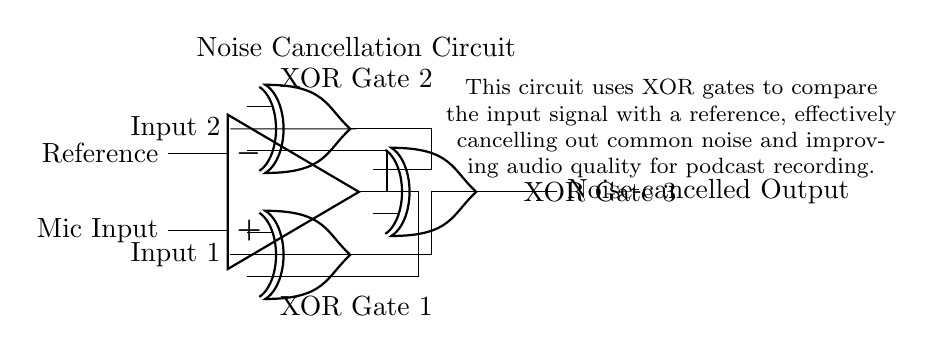What is the type of the main logic gates used in this circuit? The main logic gates used in this circuit are XOR gates, indicated by the symbols labeled in the diagram.
Answer: XOR gates How many XOR gates are present in the circuit? There are three XOR gates shown in the circuit, as seen from the labels beside the symbols.
Answer: Three What is the purpose of the operational amplifier in this circuit? The operational amplifier serves to amplify the microphone input signal, which is then fed into the XOR gates for noise cancellation.
Answer: Amplification What is the output of the circuit labeled as? The output of the circuit is labeled as "Noise-cancelled Output," indicating that the function of the circuit is to reduce unwanted noise.
Answer: Noise-cancelled Output How do the XOR gates contribute to noise cancellation? The XOR gates compare the input signal to a reference signal and effectively cancel out common noises by outputting only the differences.
Answer: By comparing signals Which signals are being input to the first XOR gate? The first XOR gate receives the microphone input signal from the operational amplifier and the reference signal.
Answer: Microphone input and reference signal 